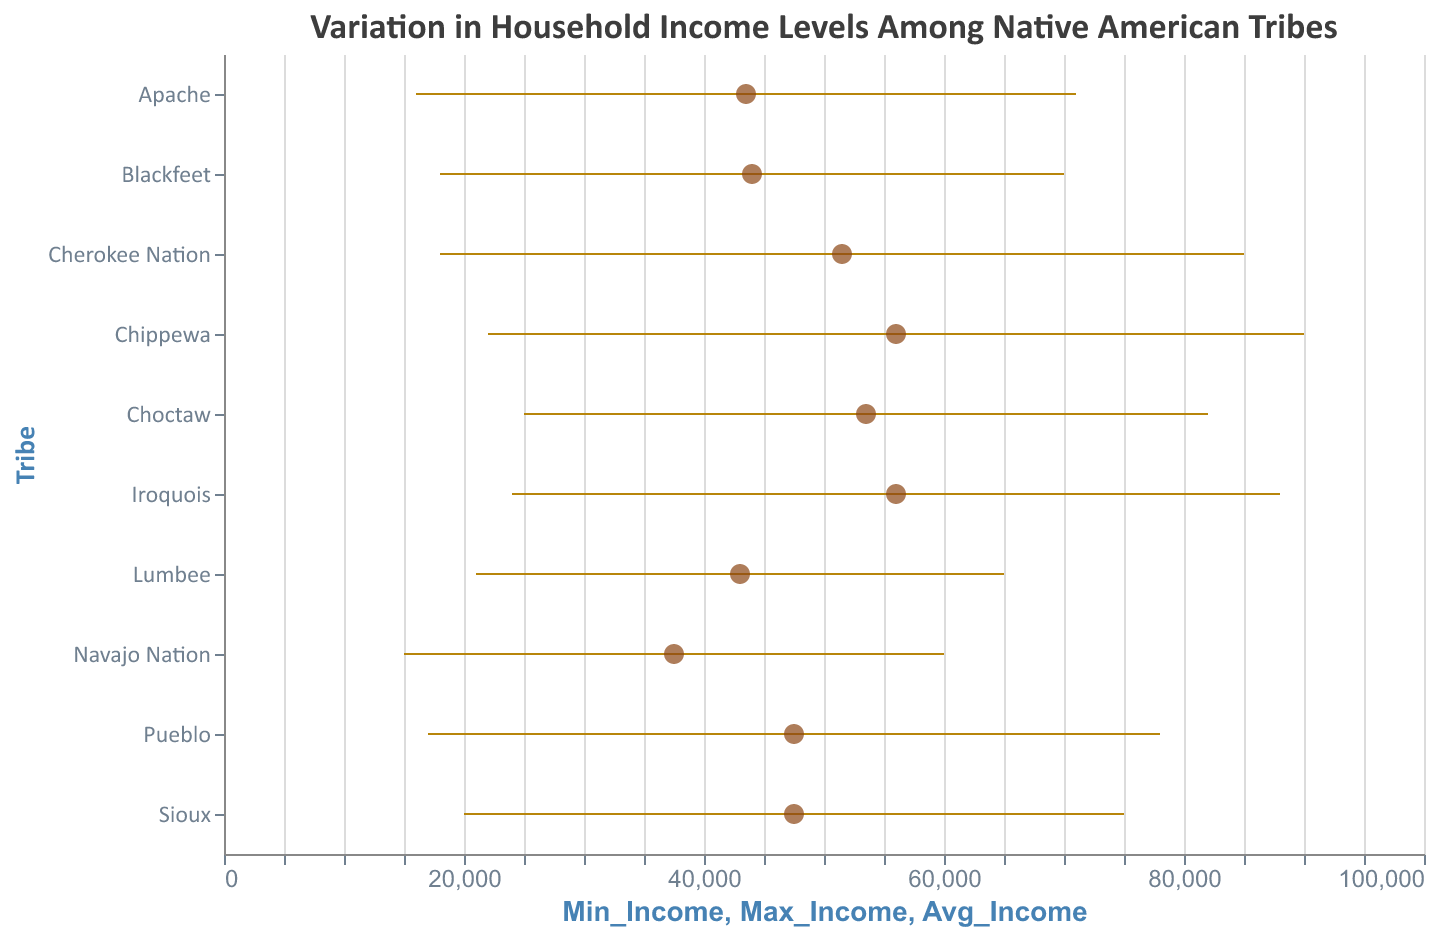Which tribe has the highest average household income? To determine this, we need to look at the data points represented as filled circles and find the highest value on the income axis. The Chippewa and Iroquois tribes both have the highest average household income at $56,000.
Answer: Chippewa and Iroquois Which tribe has the widest range of household income? To find the widest range, we look at the length of the lines (rules) representing the range of incomes for each tribe. The Cherokee Nation has the widest range, from $18,000 to $85,000, which is $67,000.
Answer: Cherokee Nation Which tribe has the lowest minimum household income? To identify the lowest minimum income, compare the starting points on the left end of the income ranges. The Navajo Nation has the lowest minimum household income at $15,000.
Answer: Navajo Nation How does the average household income of the Apache tribe compare to that of the Pueblo tribe? Look at the locations of the filled circles for both tribes. The average income for the Apache tribe is $43,500, and for the Pueblo tribe, it is $47,500. The Apache's average income is $4,000 less than the Pueblo's.
Answer: $4,000 less Calculate the difference between the highest and lowest maximum household incomes among the tribes. Find the highest and lowest maximum incomes, which are for the Chippewa ($90,000) and Lumbee ($65,000) tribes respectively. Subtracting the lowest from the highest gives $90,000 - $65,000 = $25,000.
Answer: $25,000 What is the average of the minimum household incomes across all tribes? Add all minimum incomes: $15,000 + $18,000 + $20,000 + $22,000 + $25,000 + $16,000 + $21,000 + $18,000 + $24,000 + $17,000 = $196,000. Divide by the number of tribes (10), so the average is $196,000 / 10 = $19,600.
Answer: $19,600 Compare the range of household income for the Navajo Nation and Apache tribes. Which one is larger? The Navajo Nation ranges from $15,000 to $60,000 ($45,000 range), and the Apache ranges from $16,000 to $71,000 ($55,000 range). The Apache tribe has a larger income range.
Answer: Apache What is the mid-point of household income for the Choctaw tribe? The mid-point can be found by averaging the minimum and maximum values for the Choctaw tribe. ($25,000 + $82,000) / 2 = $53,500.
Answer: $53,500 Which tribe has the smallest range of household income? To determine the smallest range, compare the lengths of the lines representing each tribe’s income range. The Lumbee tribe has the smallest range from $21,000 to $65,000, which is $44,000.
Answer: Lumbee How many tribes have an average household income below $50,000? Identify and count the filled circles that are positioned below $50,000 on the income axis. They are the Navajo Nation, Apache, Lumbee, and Blackfeet — a total of 4 tribes.
Answer: 4 